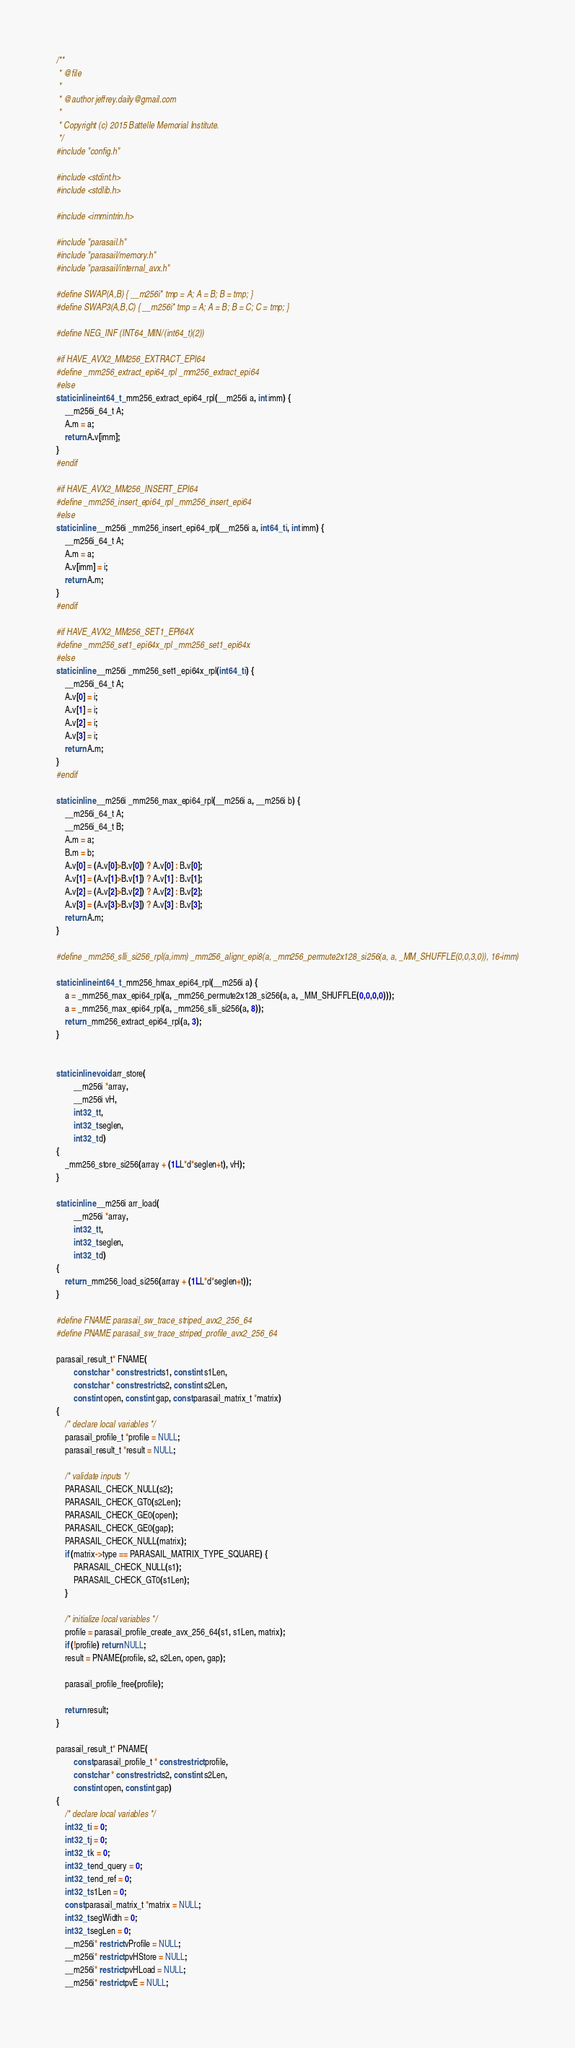<code> <loc_0><loc_0><loc_500><loc_500><_C_>/**
 * @file
 *
 * @author jeffrey.daily@gmail.com
 *
 * Copyright (c) 2015 Battelle Memorial Institute.
 */
#include "config.h"

#include <stdint.h>
#include <stdlib.h>

#include <immintrin.h>

#include "parasail.h"
#include "parasail/memory.h"
#include "parasail/internal_avx.h"

#define SWAP(A,B) { __m256i* tmp = A; A = B; B = tmp; }
#define SWAP3(A,B,C) { __m256i* tmp = A; A = B; B = C; C = tmp; }

#define NEG_INF (INT64_MIN/(int64_t)(2))

#if HAVE_AVX2_MM256_EXTRACT_EPI64
#define _mm256_extract_epi64_rpl _mm256_extract_epi64
#else
static inline int64_t _mm256_extract_epi64_rpl(__m256i a, int imm) {
    __m256i_64_t A;
    A.m = a;
    return A.v[imm];
}
#endif

#if HAVE_AVX2_MM256_INSERT_EPI64
#define _mm256_insert_epi64_rpl _mm256_insert_epi64
#else
static inline __m256i _mm256_insert_epi64_rpl(__m256i a, int64_t i, int imm) {
    __m256i_64_t A;
    A.m = a;
    A.v[imm] = i;
    return A.m;
}
#endif

#if HAVE_AVX2_MM256_SET1_EPI64X
#define _mm256_set1_epi64x_rpl _mm256_set1_epi64x
#else
static inline __m256i _mm256_set1_epi64x_rpl(int64_t i) {
    __m256i_64_t A;
    A.v[0] = i;
    A.v[1] = i;
    A.v[2] = i;
    A.v[3] = i;
    return A.m;
}
#endif

static inline __m256i _mm256_max_epi64_rpl(__m256i a, __m256i b) {
    __m256i_64_t A;
    __m256i_64_t B;
    A.m = a;
    B.m = b;
    A.v[0] = (A.v[0]>B.v[0]) ? A.v[0] : B.v[0];
    A.v[1] = (A.v[1]>B.v[1]) ? A.v[1] : B.v[1];
    A.v[2] = (A.v[2]>B.v[2]) ? A.v[2] : B.v[2];
    A.v[3] = (A.v[3]>B.v[3]) ? A.v[3] : B.v[3];
    return A.m;
}

#define _mm256_slli_si256_rpl(a,imm) _mm256_alignr_epi8(a, _mm256_permute2x128_si256(a, a, _MM_SHUFFLE(0,0,3,0)), 16-imm)

static inline int64_t _mm256_hmax_epi64_rpl(__m256i a) {
    a = _mm256_max_epi64_rpl(a, _mm256_permute2x128_si256(a, a, _MM_SHUFFLE(0,0,0,0)));
    a = _mm256_max_epi64_rpl(a, _mm256_slli_si256(a, 8));
    return _mm256_extract_epi64_rpl(a, 3);
}


static inline void arr_store(
        __m256i *array,
        __m256i vH,
        int32_t t,
        int32_t seglen,
        int32_t d)
{
    _mm256_store_si256(array + (1LL*d*seglen+t), vH);
}

static inline __m256i arr_load(
        __m256i *array,
        int32_t t,
        int32_t seglen,
        int32_t d)
{
    return _mm256_load_si256(array + (1LL*d*seglen+t));
}

#define FNAME parasail_sw_trace_striped_avx2_256_64
#define PNAME parasail_sw_trace_striped_profile_avx2_256_64

parasail_result_t* FNAME(
        const char * const restrict s1, const int s1Len,
        const char * const restrict s2, const int s2Len,
        const int open, const int gap, const parasail_matrix_t *matrix)
{
    /* declare local variables */
    parasail_profile_t *profile = NULL;
    parasail_result_t *result = NULL;

    /* validate inputs */
    PARASAIL_CHECK_NULL(s2);
    PARASAIL_CHECK_GT0(s2Len);
    PARASAIL_CHECK_GE0(open);
    PARASAIL_CHECK_GE0(gap);
    PARASAIL_CHECK_NULL(matrix);
    if (matrix->type == PARASAIL_MATRIX_TYPE_SQUARE) {
        PARASAIL_CHECK_NULL(s1);
        PARASAIL_CHECK_GT0(s1Len);
    }

    /* initialize local variables */
    profile = parasail_profile_create_avx_256_64(s1, s1Len, matrix);
    if (!profile) return NULL;
    result = PNAME(profile, s2, s2Len, open, gap);

    parasail_profile_free(profile);

    return result;
}

parasail_result_t* PNAME(
        const parasail_profile_t * const restrict profile,
        const char * const restrict s2, const int s2Len,
        const int open, const int gap)
{
    /* declare local variables */
    int32_t i = 0;
    int32_t j = 0;
    int32_t k = 0;
    int32_t end_query = 0;
    int32_t end_ref = 0;
    int32_t s1Len = 0;
    const parasail_matrix_t *matrix = NULL;
    int32_t segWidth = 0;
    int32_t segLen = 0;
    __m256i* restrict vProfile = NULL;
    __m256i* restrict pvHStore = NULL;
    __m256i* restrict pvHLoad = NULL;
    __m256i* restrict pvE = NULL;</code> 